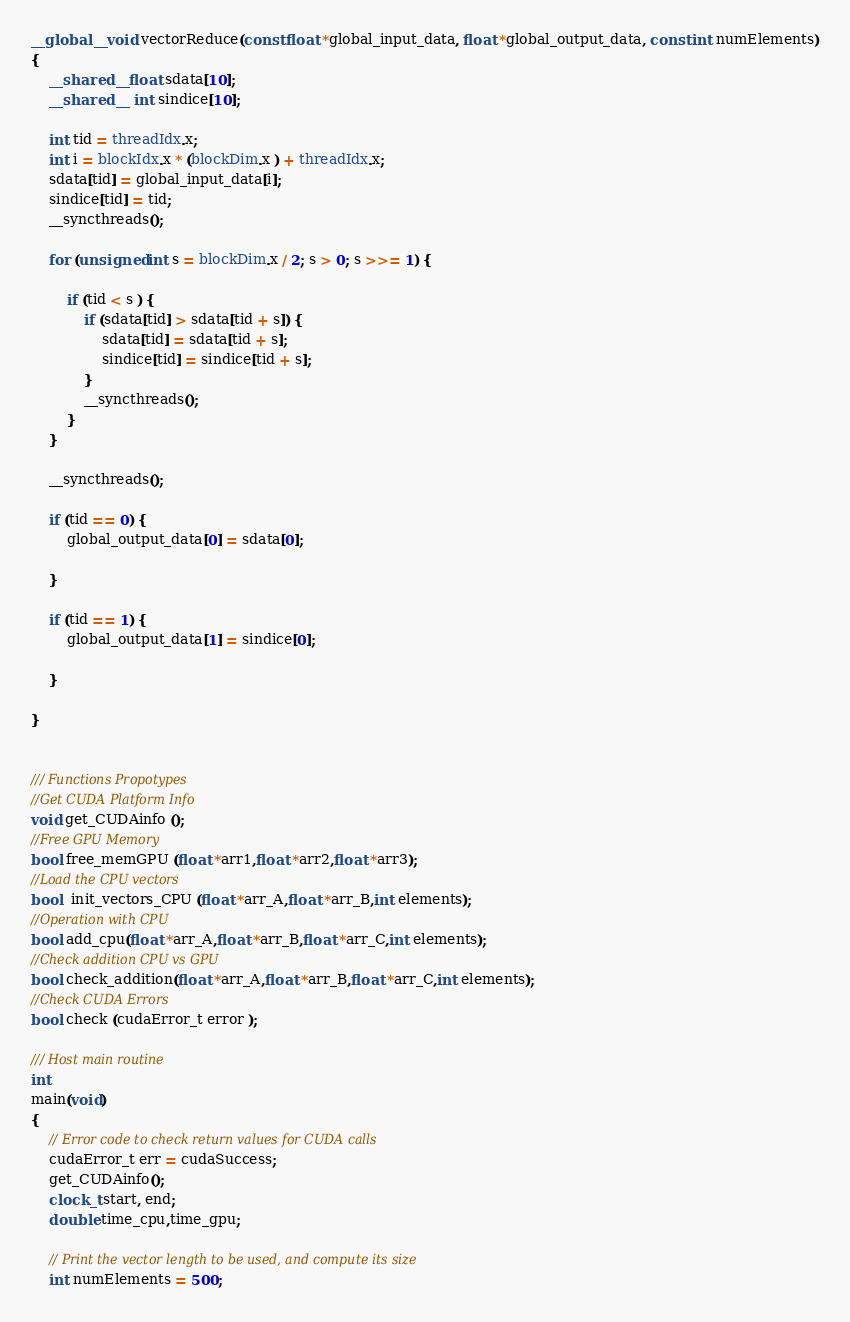Convert code to text. <code><loc_0><loc_0><loc_500><loc_500><_Cuda_>
__global__ void vectorReduce(const float *global_input_data, float *global_output_data, const int numElements)
{
    __shared__ float sdata[10];
    __shared__  int sindice[10];

    int tid = threadIdx.x;
    int i = blockIdx.x * (blockDim.x ) + threadIdx.x;
    sdata[tid] = global_input_data[i];
    sindice[tid] = tid;
    __syncthreads();

    for (unsigned int s = blockDim.x / 2; s > 0; s >>= 1) {

        if (tid < s ) {
            if (sdata[tid] > sdata[tid + s]) {
                sdata[tid] = sdata[tid + s];
                sindice[tid] = sindice[tid + s];
            }
            __syncthreads();
        }
    }

    __syncthreads();

    if (tid == 0) {
        global_output_data[0] = sdata[0];

    }

    if (tid == 1) {
        global_output_data[1] = sindice[0];

    }

}


/// Functions Propotypes
//Get CUDA Platform Info
void get_CUDAinfo ();
//Free GPU Memory
bool free_memGPU (float *arr1,float *arr2,float *arr3);
//Load the CPU vectors
bool  init_vectors_CPU (float *arr_A,float *arr_B,int elements);
//Operation with CPU
bool add_cpu(float *arr_A,float *arr_B,float *arr_C,int elements);
//Check addition CPU vs GPU
bool check_addition(float *arr_A,float *arr_B,float *arr_C,int elements);
//Check CUDA Errors
bool check (cudaError_t error );

/// Host main routine 
int
main(void)
{
    // Error code to check return values for CUDA calls
    cudaError_t err = cudaSuccess;
    get_CUDAinfo();
    clock_t start, end;
    double time_cpu,time_gpu;

    // Print the vector length to be used, and compute its size
    int numElements = 500;</code> 